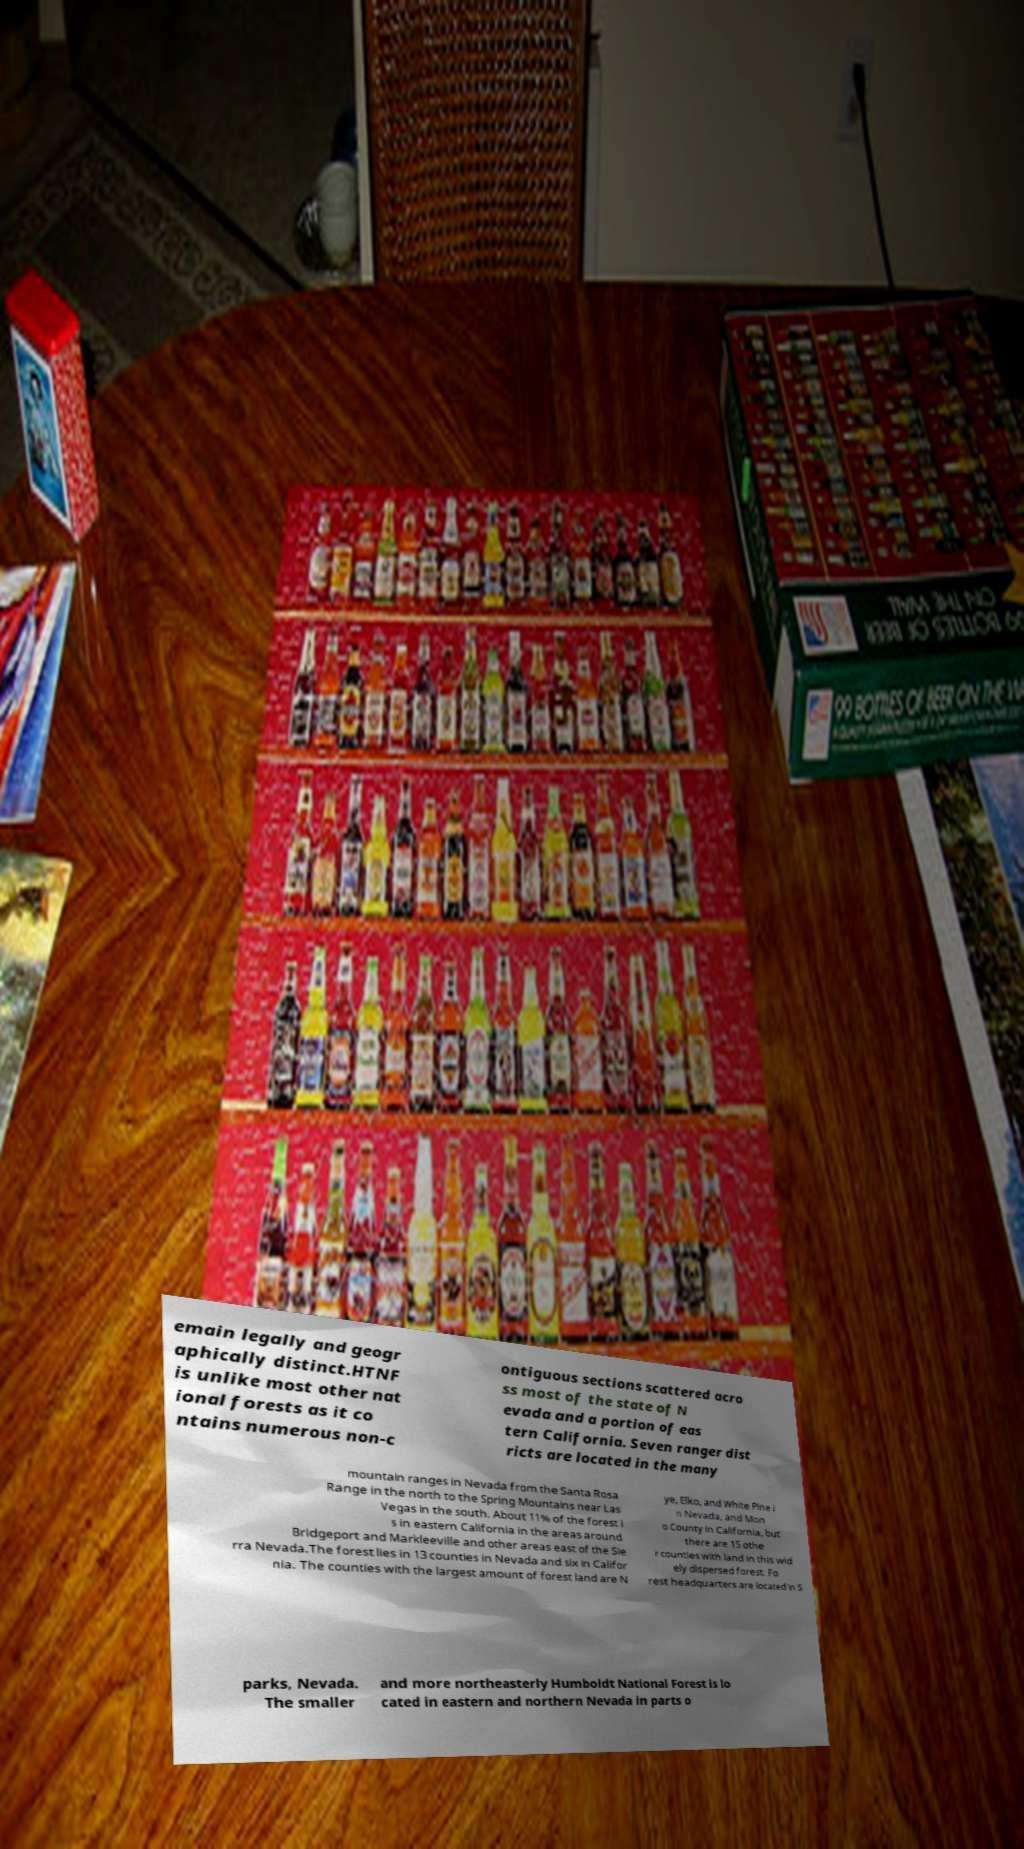Could you assist in decoding the text presented in this image and type it out clearly? emain legally and geogr aphically distinct.HTNF is unlike most other nat ional forests as it co ntains numerous non-c ontiguous sections scattered acro ss most of the state of N evada and a portion of eas tern California. Seven ranger dist ricts are located in the many mountain ranges in Nevada from the Santa Rosa Range in the north to the Spring Mountains near Las Vegas in the south. About 11% of the forest i s in eastern California in the areas around Bridgeport and Markleeville and other areas east of the Sie rra Nevada.The forest lies in 13 counties in Nevada and six in Califor nia. The counties with the largest amount of forest land are N ye, Elko, and White Pine i n Nevada, and Mon o County in California, but there are 15 othe r counties with land in this wid ely dispersed forest. Fo rest headquarters are located in S parks, Nevada. The smaller and more northeasterly Humboldt National Forest is lo cated in eastern and northern Nevada in parts o 